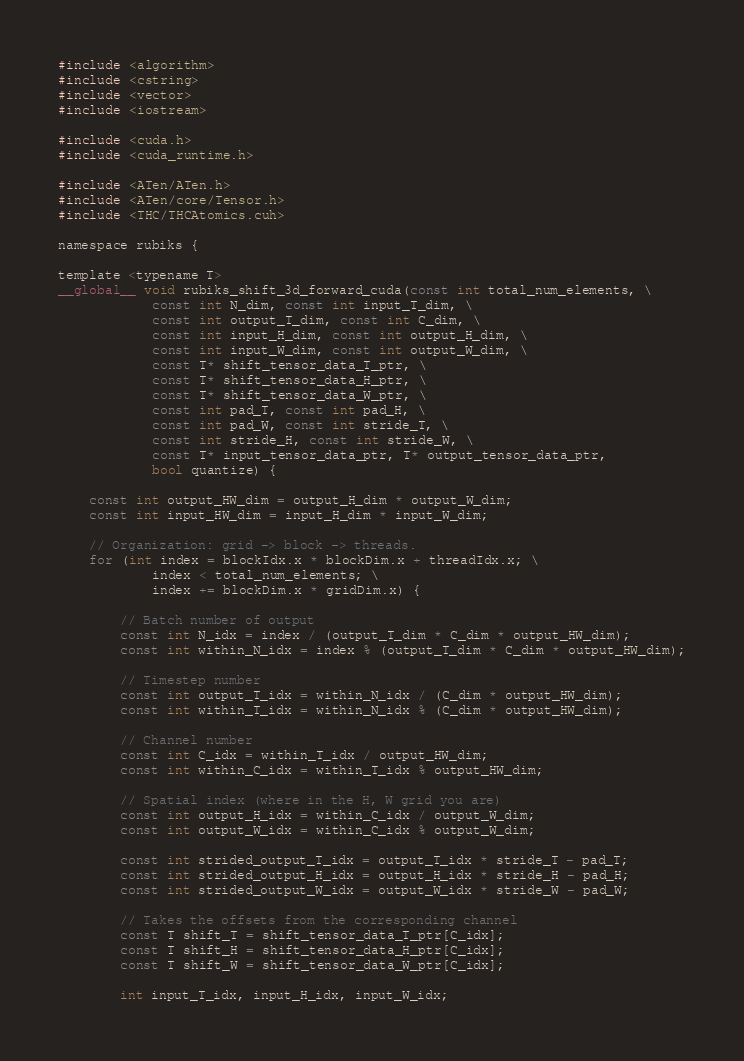Convert code to text. <code><loc_0><loc_0><loc_500><loc_500><_Cuda_>#include <algorithm>
#include <cstring>
#include <vector>
#include <iostream>

#include <cuda.h>
#include <cuda_runtime.h>

#include <ATen/ATen.h>
#include <ATen/core/Tensor.h>
#include <THC/THCAtomics.cuh>

namespace rubiks {

template <typename T>
__global__ void rubiks_shift_3d_forward_cuda(const int total_num_elements, \
            const int N_dim, const int input_T_dim, \
            const int output_T_dim, const int C_dim, \
            const int input_H_dim, const int output_H_dim, \
            const int input_W_dim, const int output_W_dim, \
            const T* shift_tensor_data_T_ptr, \
            const T* shift_tensor_data_H_ptr, \
            const T* shift_tensor_data_W_ptr, \
            const int pad_T, const int pad_H, \
            const int pad_W, const int stride_T, \
            const int stride_H, const int stride_W, \
            const T* input_tensor_data_ptr, T* output_tensor_data_ptr,
            bool quantize) {
    
    const int output_HW_dim = output_H_dim * output_W_dim;
    const int input_HW_dim = input_H_dim * input_W_dim;
    
    // Organization: grid -> block -> threads.
    for (int index = blockIdx.x * blockDim.x + threadIdx.x; \
            index < total_num_elements; \
            index += blockDim.x * gridDim.x) {
        
        // Batch number of output
		const int N_idx = index / (output_T_dim * C_dim * output_HW_dim);
		const int within_N_idx = index % (output_T_dim * C_dim * output_HW_dim);
        
        // Timestep number
		const int output_T_idx = within_N_idx / (C_dim * output_HW_dim);
		const int within_T_idx = within_N_idx % (C_dim * output_HW_dim);
        
        // Channel number
		const int C_idx = within_T_idx / output_HW_dim;
		const int within_C_idx = within_T_idx % output_HW_dim;
        
        // Spatial index (where in the H, W grid you are)
		const int output_H_idx = within_C_idx / output_W_dim;
		const int output_W_idx = within_C_idx % output_W_dim;

        const int strided_output_T_idx = output_T_idx * stride_T - pad_T;
		const int strided_output_H_idx = output_H_idx * stride_H - pad_H;
		const int strided_output_W_idx = output_W_idx * stride_W - pad_W;

        // Takes the offsets from the corresponding channel
        const T shift_T = shift_tensor_data_T_ptr[C_idx];
        const T shift_H = shift_tensor_data_H_ptr[C_idx];
        const T shift_W = shift_tensor_data_W_ptr[C_idx];

        int input_T_idx, input_H_idx, input_W_idx;
</code> 